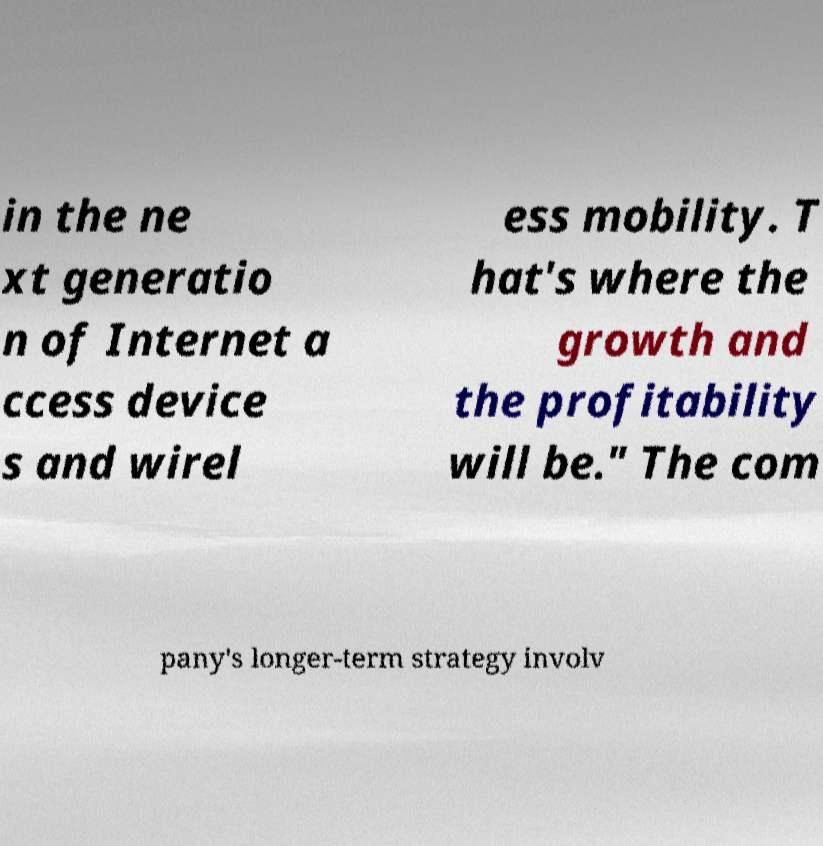Please read and relay the text visible in this image. What does it say? in the ne xt generatio n of Internet a ccess device s and wirel ess mobility. T hat's where the growth and the profitability will be." The com pany's longer-term strategy involv 